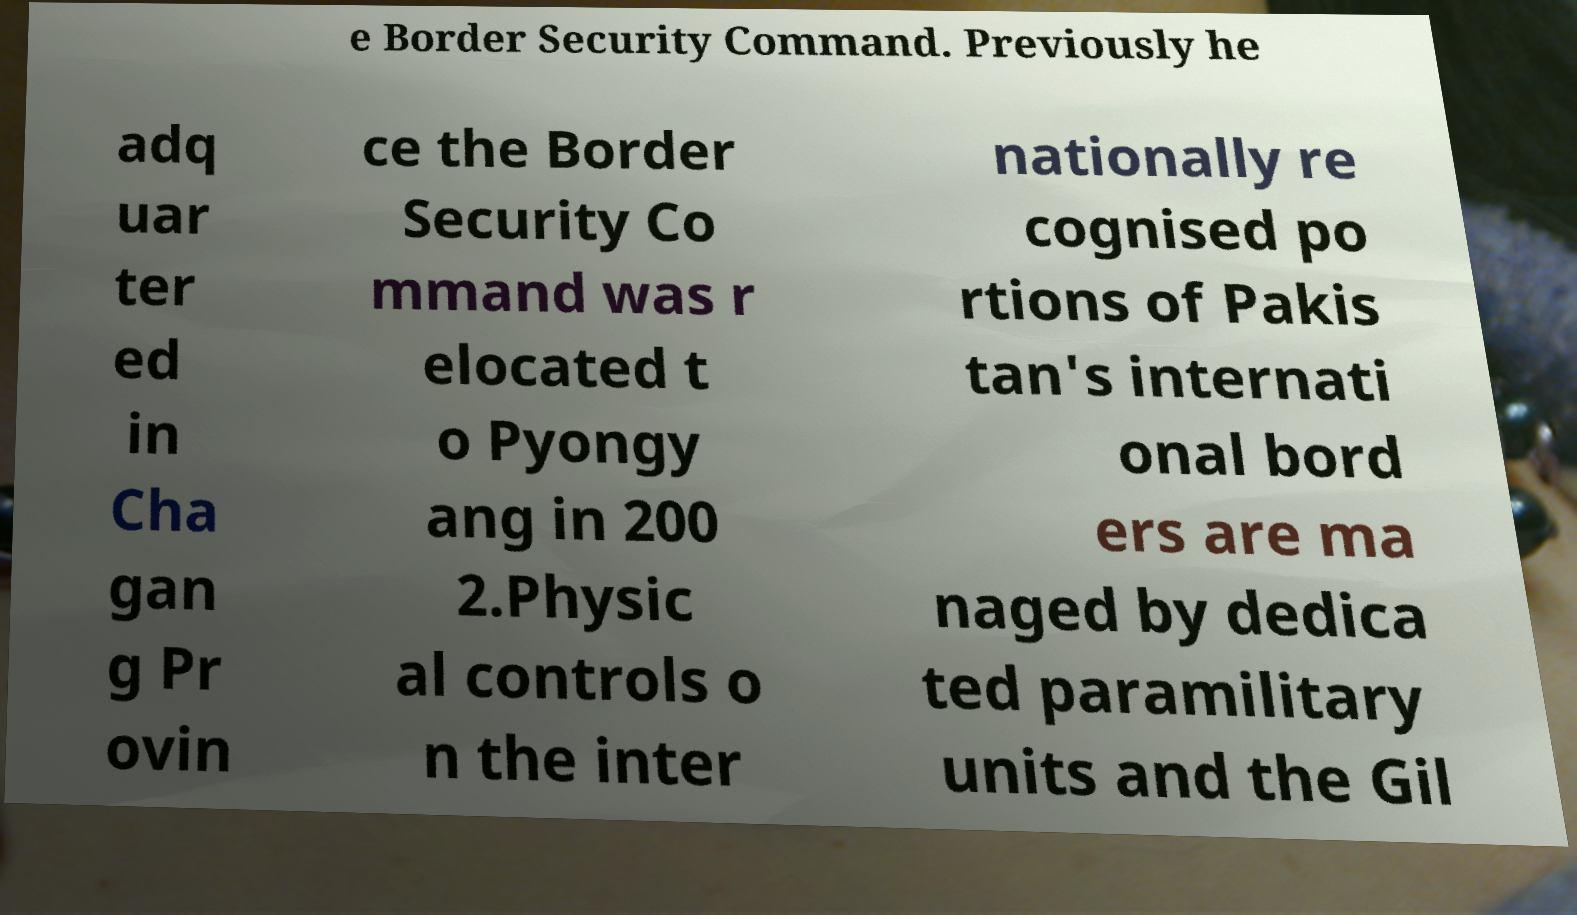Can you read and provide the text displayed in the image?This photo seems to have some interesting text. Can you extract and type it out for me? e Border Security Command. Previously he adq uar ter ed in Cha gan g Pr ovin ce the Border Security Co mmand was r elocated t o Pyongy ang in 200 2.Physic al controls o n the inter nationally re cognised po rtions of Pakis tan's internati onal bord ers are ma naged by dedica ted paramilitary units and the Gil 